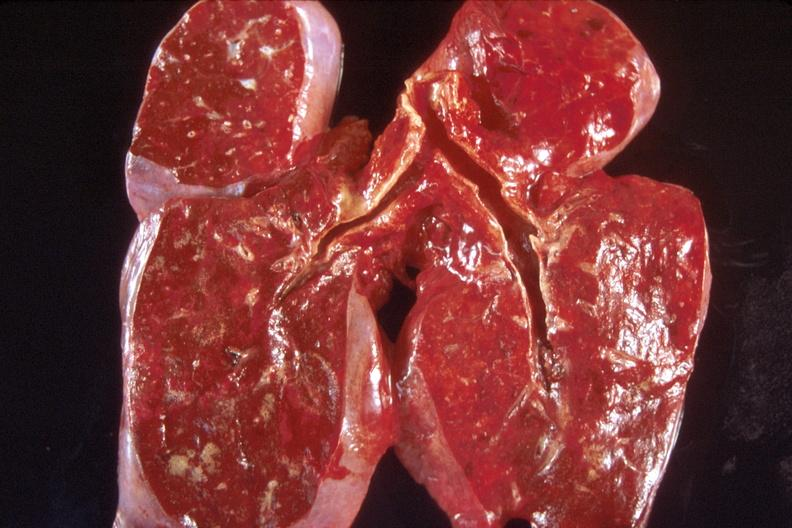does gout show lung, congestion?
Answer the question using a single word or phrase. No 